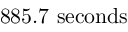<formula> <loc_0><loc_0><loc_500><loc_500>8 8 5 . 7 \ s e c o n d s</formula> 